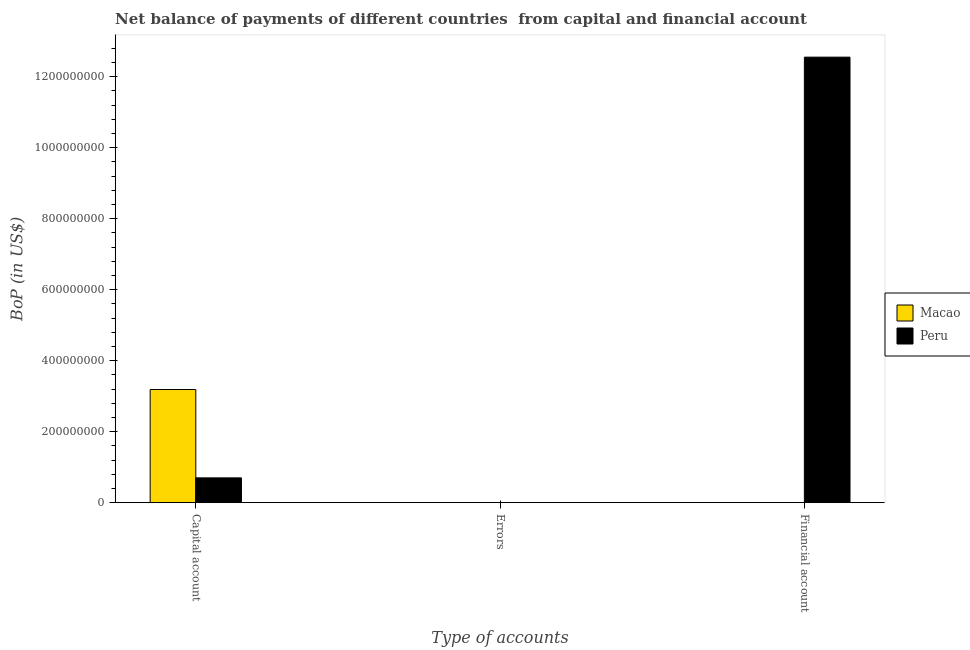How many different coloured bars are there?
Ensure brevity in your answer.  2. How many bars are there on the 1st tick from the left?
Offer a very short reply. 2. What is the label of the 2nd group of bars from the left?
Your answer should be compact. Errors. What is the amount of net capital account in Peru?
Make the answer very short. 6.98e+07. Across all countries, what is the maximum amount of net capital account?
Provide a succinct answer. 3.19e+08. Across all countries, what is the minimum amount of errors?
Keep it short and to the point. 0. What is the total amount of net capital account in the graph?
Keep it short and to the point. 3.88e+08. What is the difference between the amount of net capital account in Peru and that in Macao?
Give a very brief answer. -2.49e+08. What is the difference between the amount of financial account in Peru and the amount of net capital account in Macao?
Make the answer very short. 9.36e+08. What is the average amount of net capital account per country?
Give a very brief answer. 1.94e+08. What is the difference between the amount of financial account and amount of net capital account in Peru?
Offer a very short reply. 1.18e+09. In how many countries, is the amount of net capital account greater than 440000000 US$?
Ensure brevity in your answer.  0. What is the ratio of the amount of net capital account in Macao to that in Peru?
Offer a terse response. 4.56. Is the amount of net capital account in Macao less than that in Peru?
Provide a short and direct response. No. What is the difference between the highest and the second highest amount of net capital account?
Provide a succinct answer. 2.49e+08. What is the difference between the highest and the lowest amount of net capital account?
Make the answer very short. 2.49e+08. Is the sum of the amount of net capital account in Peru and Macao greater than the maximum amount of errors across all countries?
Your answer should be compact. Yes. Is it the case that in every country, the sum of the amount of net capital account and amount of errors is greater than the amount of financial account?
Offer a terse response. No. Are all the bars in the graph horizontal?
Give a very brief answer. No. Are the values on the major ticks of Y-axis written in scientific E-notation?
Make the answer very short. No. Does the graph contain any zero values?
Your response must be concise. Yes. Does the graph contain grids?
Make the answer very short. No. Where does the legend appear in the graph?
Ensure brevity in your answer.  Center right. How many legend labels are there?
Ensure brevity in your answer.  2. How are the legend labels stacked?
Provide a short and direct response. Vertical. What is the title of the graph?
Offer a terse response. Net balance of payments of different countries  from capital and financial account. What is the label or title of the X-axis?
Your answer should be very brief. Type of accounts. What is the label or title of the Y-axis?
Provide a short and direct response. BoP (in US$). What is the BoP (in US$) in Macao in Capital account?
Your answer should be very brief. 3.19e+08. What is the BoP (in US$) in Peru in Capital account?
Your answer should be very brief. 6.98e+07. What is the BoP (in US$) in Macao in Errors?
Provide a succinct answer. 0. What is the BoP (in US$) of Macao in Financial account?
Give a very brief answer. 0. What is the BoP (in US$) of Peru in Financial account?
Make the answer very short. 1.25e+09. Across all Type of accounts, what is the maximum BoP (in US$) of Macao?
Make the answer very short. 3.19e+08. Across all Type of accounts, what is the maximum BoP (in US$) in Peru?
Provide a succinct answer. 1.25e+09. Across all Type of accounts, what is the minimum BoP (in US$) of Macao?
Your answer should be compact. 0. What is the total BoP (in US$) of Macao in the graph?
Your answer should be very brief. 3.19e+08. What is the total BoP (in US$) in Peru in the graph?
Give a very brief answer. 1.32e+09. What is the difference between the BoP (in US$) of Peru in Capital account and that in Financial account?
Your answer should be compact. -1.18e+09. What is the difference between the BoP (in US$) of Macao in Capital account and the BoP (in US$) of Peru in Financial account?
Make the answer very short. -9.36e+08. What is the average BoP (in US$) of Macao per Type of accounts?
Your answer should be compact. 1.06e+08. What is the average BoP (in US$) of Peru per Type of accounts?
Offer a very short reply. 4.42e+08. What is the difference between the BoP (in US$) in Macao and BoP (in US$) in Peru in Capital account?
Keep it short and to the point. 2.49e+08. What is the ratio of the BoP (in US$) of Peru in Capital account to that in Financial account?
Keep it short and to the point. 0.06. What is the difference between the highest and the lowest BoP (in US$) in Macao?
Offer a terse response. 3.19e+08. What is the difference between the highest and the lowest BoP (in US$) of Peru?
Your answer should be very brief. 1.25e+09. 